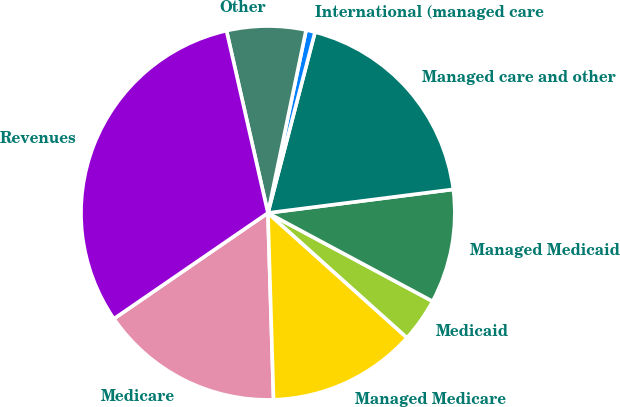Convert chart. <chart><loc_0><loc_0><loc_500><loc_500><pie_chart><fcel>Medicare<fcel>Managed Medicare<fcel>Medicaid<fcel>Managed Medicaid<fcel>Managed care and other<fcel>International (managed care<fcel>Other<fcel>Revenues<nl><fcel>15.9%<fcel>12.88%<fcel>3.8%<fcel>9.85%<fcel>18.93%<fcel>0.78%<fcel>6.83%<fcel>31.02%<nl></chart> 